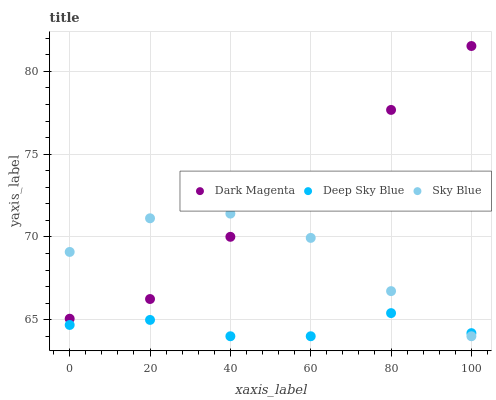Does Deep Sky Blue have the minimum area under the curve?
Answer yes or no. Yes. Does Dark Magenta have the maximum area under the curve?
Answer yes or no. Yes. Does Dark Magenta have the minimum area under the curve?
Answer yes or no. No. Does Deep Sky Blue have the maximum area under the curve?
Answer yes or no. No. Is Dark Magenta the smoothest?
Answer yes or no. Yes. Is Deep Sky Blue the roughest?
Answer yes or no. Yes. Is Deep Sky Blue the smoothest?
Answer yes or no. No. Is Dark Magenta the roughest?
Answer yes or no. No. Does Sky Blue have the lowest value?
Answer yes or no. Yes. Does Dark Magenta have the lowest value?
Answer yes or no. No. Does Dark Magenta have the highest value?
Answer yes or no. Yes. Does Deep Sky Blue have the highest value?
Answer yes or no. No. Is Deep Sky Blue less than Dark Magenta?
Answer yes or no. Yes. Is Dark Magenta greater than Deep Sky Blue?
Answer yes or no. Yes. Does Dark Magenta intersect Sky Blue?
Answer yes or no. Yes. Is Dark Magenta less than Sky Blue?
Answer yes or no. No. Is Dark Magenta greater than Sky Blue?
Answer yes or no. No. Does Deep Sky Blue intersect Dark Magenta?
Answer yes or no. No. 